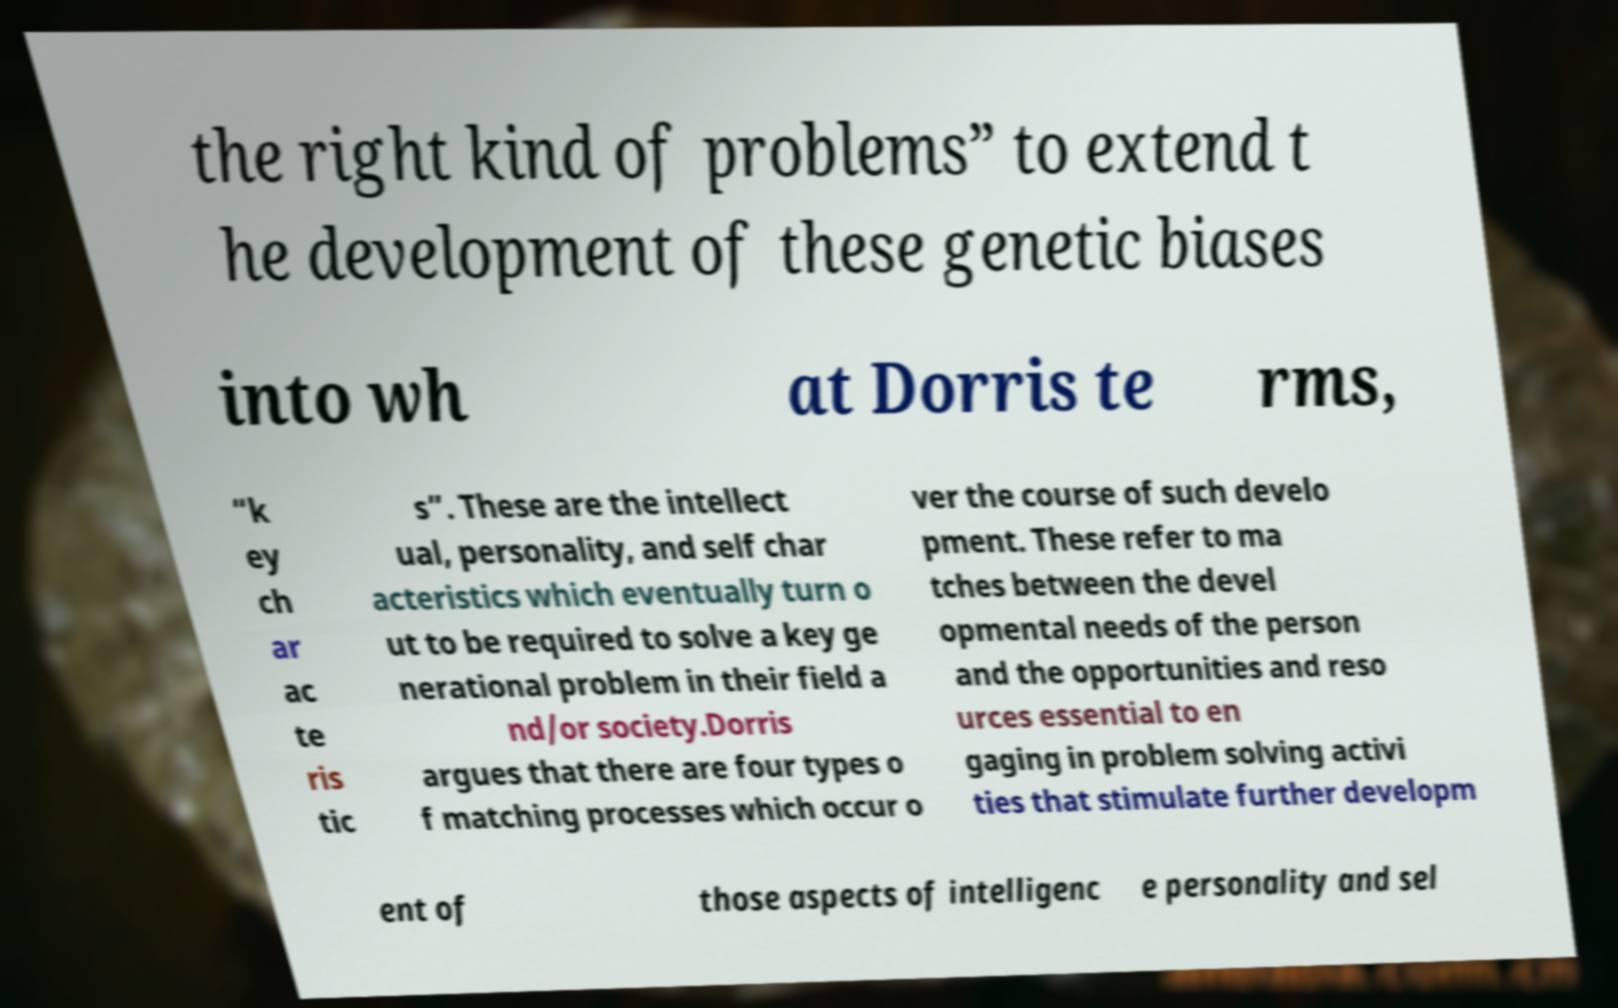Can you read and provide the text displayed in the image?This photo seems to have some interesting text. Can you extract and type it out for me? the right kind of problems” to extend t he development of these genetic biases into wh at Dorris te rms, “k ey ch ar ac te ris tic s”. These are the intellect ual, personality, and self char acteristics which eventually turn o ut to be required to solve a key ge nerational problem in their field a nd/or society.Dorris argues that there are four types o f matching processes which occur o ver the course of such develo pment. These refer to ma tches between the devel opmental needs of the person and the opportunities and reso urces essential to en gaging in problem solving activi ties that stimulate further developm ent of those aspects of intelligenc e personality and sel 